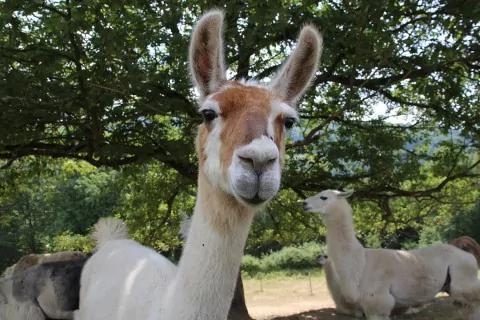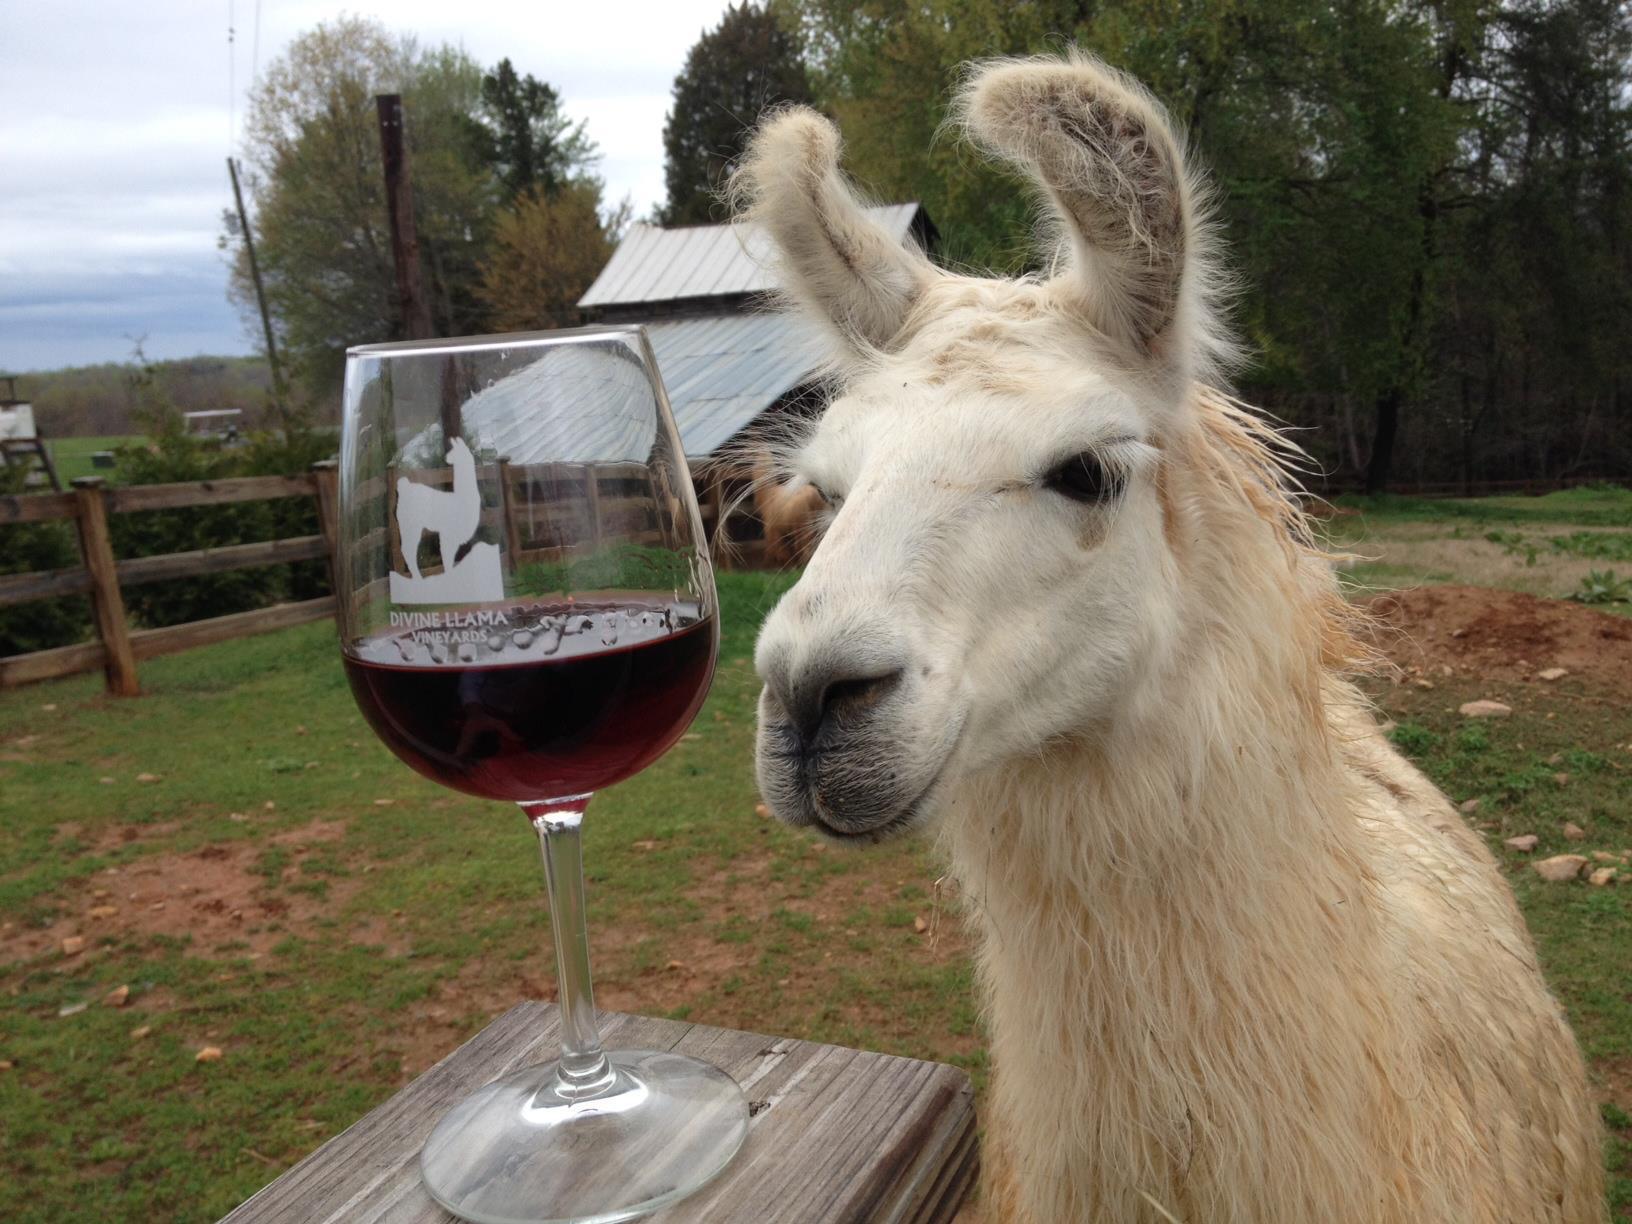The first image is the image on the left, the second image is the image on the right. Considering the images on both sides, is "Each image features exactly two llamas in the foreground." valid? Answer yes or no. No. 